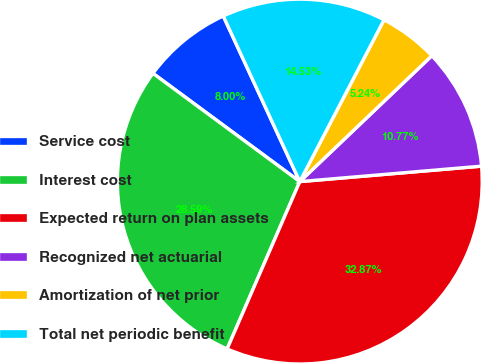Convert chart to OTSL. <chart><loc_0><loc_0><loc_500><loc_500><pie_chart><fcel>Service cost<fcel>Interest cost<fcel>Expected return on plan assets<fcel>Recognized net actuarial<fcel>Amortization of net prior<fcel>Total net periodic benefit<nl><fcel>8.0%<fcel>28.59%<fcel>32.87%<fcel>10.77%<fcel>5.24%<fcel>14.53%<nl></chart> 